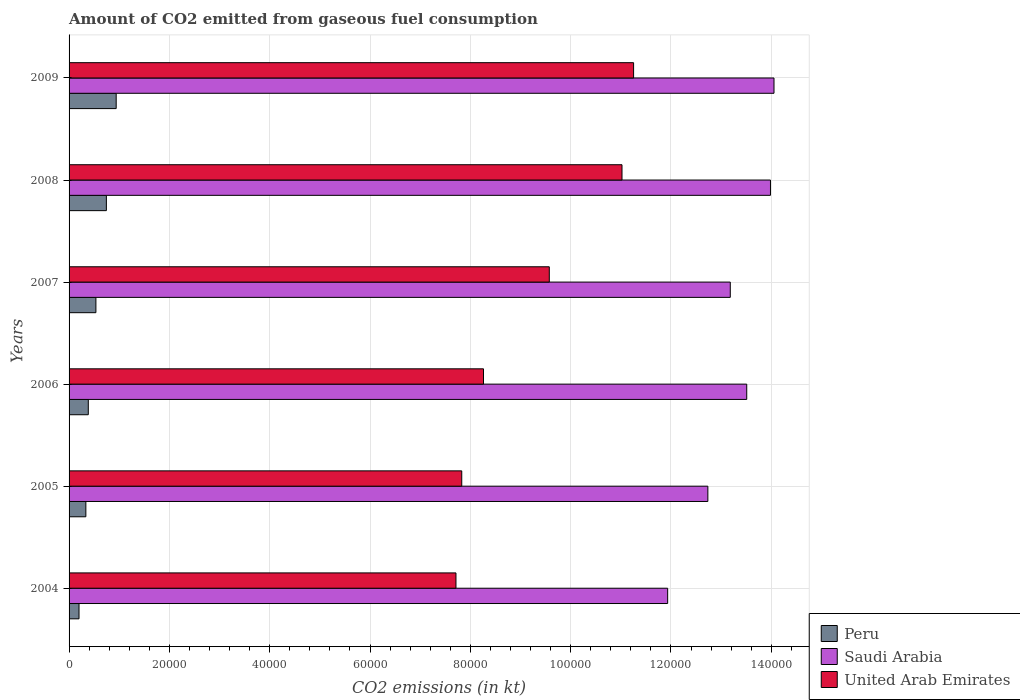Are the number of bars per tick equal to the number of legend labels?
Give a very brief answer. Yes. How many bars are there on the 4th tick from the bottom?
Your answer should be compact. 3. What is the amount of CO2 emitted in Peru in 2008?
Offer a terse response. 7436.68. Across all years, what is the maximum amount of CO2 emitted in Peru?
Keep it short and to the point. 9394.85. Across all years, what is the minimum amount of CO2 emitted in Saudi Arabia?
Offer a very short reply. 1.19e+05. What is the total amount of CO2 emitted in Saudi Arabia in the graph?
Ensure brevity in your answer.  7.94e+05. What is the difference between the amount of CO2 emitted in Peru in 2004 and that in 2006?
Give a very brief answer. -1848.17. What is the difference between the amount of CO2 emitted in United Arab Emirates in 2004 and the amount of CO2 emitted in Peru in 2007?
Keep it short and to the point. 7.18e+04. What is the average amount of CO2 emitted in Saudi Arabia per year?
Keep it short and to the point. 1.32e+05. In the year 2005, what is the difference between the amount of CO2 emitted in Saudi Arabia and amount of CO2 emitted in United Arab Emirates?
Ensure brevity in your answer.  4.91e+04. In how many years, is the amount of CO2 emitted in United Arab Emirates greater than 120000 kt?
Ensure brevity in your answer.  0. What is the ratio of the amount of CO2 emitted in United Arab Emirates in 2006 to that in 2009?
Offer a very short reply. 0.73. Is the amount of CO2 emitted in United Arab Emirates in 2005 less than that in 2006?
Provide a succinct answer. Yes. What is the difference between the highest and the second highest amount of CO2 emitted in Saudi Arabia?
Your answer should be compact. 704.06. What is the difference between the highest and the lowest amount of CO2 emitted in Peru?
Ensure brevity in your answer.  7411.01. In how many years, is the amount of CO2 emitted in United Arab Emirates greater than the average amount of CO2 emitted in United Arab Emirates taken over all years?
Your answer should be very brief. 3. Is the sum of the amount of CO2 emitted in Saudi Arabia in 2007 and 2009 greater than the maximum amount of CO2 emitted in Peru across all years?
Ensure brevity in your answer.  Yes. What does the 2nd bar from the top in 2007 represents?
Your answer should be very brief. Saudi Arabia. What does the 2nd bar from the bottom in 2009 represents?
Keep it short and to the point. Saudi Arabia. Is it the case that in every year, the sum of the amount of CO2 emitted in Saudi Arabia and amount of CO2 emitted in United Arab Emirates is greater than the amount of CO2 emitted in Peru?
Ensure brevity in your answer.  Yes. How many bars are there?
Your answer should be compact. 18. Are all the bars in the graph horizontal?
Offer a very short reply. Yes. How many years are there in the graph?
Offer a very short reply. 6. What is the difference between two consecutive major ticks on the X-axis?
Your answer should be compact. 2.00e+04. Does the graph contain grids?
Provide a succinct answer. Yes. How are the legend labels stacked?
Your response must be concise. Vertical. What is the title of the graph?
Offer a very short reply. Amount of CO2 emitted from gaseous fuel consumption. What is the label or title of the X-axis?
Make the answer very short. CO2 emissions (in kt). What is the label or title of the Y-axis?
Ensure brevity in your answer.  Years. What is the CO2 emissions (in kt) of Peru in 2004?
Keep it short and to the point. 1983.85. What is the CO2 emissions (in kt) in Saudi Arabia in 2004?
Your answer should be very brief. 1.19e+05. What is the CO2 emissions (in kt) in United Arab Emirates in 2004?
Provide a short and direct response. 7.71e+04. What is the CO2 emissions (in kt) of Peru in 2005?
Provide a succinct answer. 3347.97. What is the CO2 emissions (in kt) in Saudi Arabia in 2005?
Make the answer very short. 1.27e+05. What is the CO2 emissions (in kt) of United Arab Emirates in 2005?
Ensure brevity in your answer.  7.83e+04. What is the CO2 emissions (in kt) in Peru in 2006?
Your response must be concise. 3832.01. What is the CO2 emissions (in kt) in Saudi Arabia in 2006?
Ensure brevity in your answer.  1.35e+05. What is the CO2 emissions (in kt) of United Arab Emirates in 2006?
Your response must be concise. 8.26e+04. What is the CO2 emissions (in kt) in Peru in 2007?
Offer a very short reply. 5350.15. What is the CO2 emissions (in kt) of Saudi Arabia in 2007?
Provide a succinct answer. 1.32e+05. What is the CO2 emissions (in kt) of United Arab Emirates in 2007?
Offer a terse response. 9.57e+04. What is the CO2 emissions (in kt) of Peru in 2008?
Offer a terse response. 7436.68. What is the CO2 emissions (in kt) in Saudi Arabia in 2008?
Your answer should be very brief. 1.40e+05. What is the CO2 emissions (in kt) in United Arab Emirates in 2008?
Offer a terse response. 1.10e+05. What is the CO2 emissions (in kt) in Peru in 2009?
Provide a short and direct response. 9394.85. What is the CO2 emissions (in kt) in Saudi Arabia in 2009?
Offer a very short reply. 1.41e+05. What is the CO2 emissions (in kt) in United Arab Emirates in 2009?
Offer a very short reply. 1.13e+05. Across all years, what is the maximum CO2 emissions (in kt) in Peru?
Your response must be concise. 9394.85. Across all years, what is the maximum CO2 emissions (in kt) in Saudi Arabia?
Your answer should be compact. 1.41e+05. Across all years, what is the maximum CO2 emissions (in kt) of United Arab Emirates?
Your answer should be compact. 1.13e+05. Across all years, what is the minimum CO2 emissions (in kt) of Peru?
Keep it short and to the point. 1983.85. Across all years, what is the minimum CO2 emissions (in kt) in Saudi Arabia?
Your answer should be compact. 1.19e+05. Across all years, what is the minimum CO2 emissions (in kt) of United Arab Emirates?
Keep it short and to the point. 7.71e+04. What is the total CO2 emissions (in kt) of Peru in the graph?
Offer a very short reply. 3.13e+04. What is the total CO2 emissions (in kt) of Saudi Arabia in the graph?
Provide a succinct answer. 7.94e+05. What is the total CO2 emissions (in kt) of United Arab Emirates in the graph?
Your answer should be very brief. 5.57e+05. What is the difference between the CO2 emissions (in kt) in Peru in 2004 and that in 2005?
Keep it short and to the point. -1364.12. What is the difference between the CO2 emissions (in kt) of Saudi Arabia in 2004 and that in 2005?
Your answer should be very brief. -8016.06. What is the difference between the CO2 emissions (in kt) of United Arab Emirates in 2004 and that in 2005?
Your response must be concise. -1151.44. What is the difference between the CO2 emissions (in kt) of Peru in 2004 and that in 2006?
Provide a succinct answer. -1848.17. What is the difference between the CO2 emissions (in kt) in Saudi Arabia in 2004 and that in 2006?
Offer a terse response. -1.58e+04. What is the difference between the CO2 emissions (in kt) of United Arab Emirates in 2004 and that in 2006?
Your answer should be very brief. -5489.5. What is the difference between the CO2 emissions (in kt) of Peru in 2004 and that in 2007?
Offer a terse response. -3366.31. What is the difference between the CO2 emissions (in kt) of Saudi Arabia in 2004 and that in 2007?
Your response must be concise. -1.25e+04. What is the difference between the CO2 emissions (in kt) in United Arab Emirates in 2004 and that in 2007?
Make the answer very short. -1.86e+04. What is the difference between the CO2 emissions (in kt) of Peru in 2004 and that in 2008?
Ensure brevity in your answer.  -5452.83. What is the difference between the CO2 emissions (in kt) of Saudi Arabia in 2004 and that in 2008?
Your answer should be compact. -2.05e+04. What is the difference between the CO2 emissions (in kt) in United Arab Emirates in 2004 and that in 2008?
Provide a short and direct response. -3.31e+04. What is the difference between the CO2 emissions (in kt) of Peru in 2004 and that in 2009?
Provide a succinct answer. -7411.01. What is the difference between the CO2 emissions (in kt) in Saudi Arabia in 2004 and that in 2009?
Offer a very short reply. -2.12e+04. What is the difference between the CO2 emissions (in kt) of United Arab Emirates in 2004 and that in 2009?
Offer a very short reply. -3.54e+04. What is the difference between the CO2 emissions (in kt) in Peru in 2005 and that in 2006?
Your answer should be very brief. -484.04. What is the difference between the CO2 emissions (in kt) in Saudi Arabia in 2005 and that in 2006?
Your answer should be compact. -7752.04. What is the difference between the CO2 emissions (in kt) of United Arab Emirates in 2005 and that in 2006?
Make the answer very short. -4338.06. What is the difference between the CO2 emissions (in kt) of Peru in 2005 and that in 2007?
Your response must be concise. -2002.18. What is the difference between the CO2 emissions (in kt) in Saudi Arabia in 2005 and that in 2007?
Your response must be concise. -4470.07. What is the difference between the CO2 emissions (in kt) of United Arab Emirates in 2005 and that in 2007?
Offer a very short reply. -1.75e+04. What is the difference between the CO2 emissions (in kt) of Peru in 2005 and that in 2008?
Make the answer very short. -4088.7. What is the difference between the CO2 emissions (in kt) of Saudi Arabia in 2005 and that in 2008?
Offer a terse response. -1.25e+04. What is the difference between the CO2 emissions (in kt) in United Arab Emirates in 2005 and that in 2008?
Provide a succinct answer. -3.20e+04. What is the difference between the CO2 emissions (in kt) in Peru in 2005 and that in 2009?
Ensure brevity in your answer.  -6046.88. What is the difference between the CO2 emissions (in kt) of Saudi Arabia in 2005 and that in 2009?
Ensure brevity in your answer.  -1.32e+04. What is the difference between the CO2 emissions (in kt) of United Arab Emirates in 2005 and that in 2009?
Ensure brevity in your answer.  -3.43e+04. What is the difference between the CO2 emissions (in kt) in Peru in 2006 and that in 2007?
Offer a terse response. -1518.14. What is the difference between the CO2 emissions (in kt) in Saudi Arabia in 2006 and that in 2007?
Keep it short and to the point. 3281.97. What is the difference between the CO2 emissions (in kt) of United Arab Emirates in 2006 and that in 2007?
Your answer should be compact. -1.31e+04. What is the difference between the CO2 emissions (in kt) in Peru in 2006 and that in 2008?
Your response must be concise. -3604.66. What is the difference between the CO2 emissions (in kt) of Saudi Arabia in 2006 and that in 2008?
Give a very brief answer. -4730.43. What is the difference between the CO2 emissions (in kt) of United Arab Emirates in 2006 and that in 2008?
Your response must be concise. -2.76e+04. What is the difference between the CO2 emissions (in kt) of Peru in 2006 and that in 2009?
Offer a terse response. -5562.84. What is the difference between the CO2 emissions (in kt) of Saudi Arabia in 2006 and that in 2009?
Offer a very short reply. -5434.49. What is the difference between the CO2 emissions (in kt) of United Arab Emirates in 2006 and that in 2009?
Your answer should be compact. -2.99e+04. What is the difference between the CO2 emissions (in kt) in Peru in 2007 and that in 2008?
Make the answer very short. -2086.52. What is the difference between the CO2 emissions (in kt) of Saudi Arabia in 2007 and that in 2008?
Your answer should be very brief. -8012.4. What is the difference between the CO2 emissions (in kt) in United Arab Emirates in 2007 and that in 2008?
Offer a terse response. -1.45e+04. What is the difference between the CO2 emissions (in kt) in Peru in 2007 and that in 2009?
Make the answer very short. -4044.7. What is the difference between the CO2 emissions (in kt) in Saudi Arabia in 2007 and that in 2009?
Make the answer very short. -8716.46. What is the difference between the CO2 emissions (in kt) of United Arab Emirates in 2007 and that in 2009?
Ensure brevity in your answer.  -1.68e+04. What is the difference between the CO2 emissions (in kt) of Peru in 2008 and that in 2009?
Your answer should be very brief. -1958.18. What is the difference between the CO2 emissions (in kt) in Saudi Arabia in 2008 and that in 2009?
Make the answer very short. -704.06. What is the difference between the CO2 emissions (in kt) in United Arab Emirates in 2008 and that in 2009?
Your answer should be very brief. -2310.21. What is the difference between the CO2 emissions (in kt) of Peru in 2004 and the CO2 emissions (in kt) of Saudi Arabia in 2005?
Your answer should be very brief. -1.25e+05. What is the difference between the CO2 emissions (in kt) of Peru in 2004 and the CO2 emissions (in kt) of United Arab Emirates in 2005?
Make the answer very short. -7.63e+04. What is the difference between the CO2 emissions (in kt) in Saudi Arabia in 2004 and the CO2 emissions (in kt) in United Arab Emirates in 2005?
Provide a succinct answer. 4.11e+04. What is the difference between the CO2 emissions (in kt) in Peru in 2004 and the CO2 emissions (in kt) in Saudi Arabia in 2006?
Ensure brevity in your answer.  -1.33e+05. What is the difference between the CO2 emissions (in kt) in Peru in 2004 and the CO2 emissions (in kt) in United Arab Emirates in 2006?
Provide a succinct answer. -8.06e+04. What is the difference between the CO2 emissions (in kt) of Saudi Arabia in 2004 and the CO2 emissions (in kt) of United Arab Emirates in 2006?
Keep it short and to the point. 3.67e+04. What is the difference between the CO2 emissions (in kt) in Peru in 2004 and the CO2 emissions (in kt) in Saudi Arabia in 2007?
Keep it short and to the point. -1.30e+05. What is the difference between the CO2 emissions (in kt) of Peru in 2004 and the CO2 emissions (in kt) of United Arab Emirates in 2007?
Ensure brevity in your answer.  -9.38e+04. What is the difference between the CO2 emissions (in kt) in Saudi Arabia in 2004 and the CO2 emissions (in kt) in United Arab Emirates in 2007?
Offer a terse response. 2.36e+04. What is the difference between the CO2 emissions (in kt) in Peru in 2004 and the CO2 emissions (in kt) in Saudi Arabia in 2008?
Ensure brevity in your answer.  -1.38e+05. What is the difference between the CO2 emissions (in kt) of Peru in 2004 and the CO2 emissions (in kt) of United Arab Emirates in 2008?
Your response must be concise. -1.08e+05. What is the difference between the CO2 emissions (in kt) of Saudi Arabia in 2004 and the CO2 emissions (in kt) of United Arab Emirates in 2008?
Offer a very short reply. 9101.49. What is the difference between the CO2 emissions (in kt) in Peru in 2004 and the CO2 emissions (in kt) in Saudi Arabia in 2009?
Ensure brevity in your answer.  -1.39e+05. What is the difference between the CO2 emissions (in kt) of Peru in 2004 and the CO2 emissions (in kt) of United Arab Emirates in 2009?
Provide a short and direct response. -1.11e+05. What is the difference between the CO2 emissions (in kt) of Saudi Arabia in 2004 and the CO2 emissions (in kt) of United Arab Emirates in 2009?
Offer a very short reply. 6791.28. What is the difference between the CO2 emissions (in kt) in Peru in 2005 and the CO2 emissions (in kt) in Saudi Arabia in 2006?
Provide a succinct answer. -1.32e+05. What is the difference between the CO2 emissions (in kt) in Peru in 2005 and the CO2 emissions (in kt) in United Arab Emirates in 2006?
Offer a very short reply. -7.93e+04. What is the difference between the CO2 emissions (in kt) in Saudi Arabia in 2005 and the CO2 emissions (in kt) in United Arab Emirates in 2006?
Your response must be concise. 4.47e+04. What is the difference between the CO2 emissions (in kt) of Peru in 2005 and the CO2 emissions (in kt) of Saudi Arabia in 2007?
Provide a succinct answer. -1.28e+05. What is the difference between the CO2 emissions (in kt) in Peru in 2005 and the CO2 emissions (in kt) in United Arab Emirates in 2007?
Your response must be concise. -9.24e+04. What is the difference between the CO2 emissions (in kt) in Saudi Arabia in 2005 and the CO2 emissions (in kt) in United Arab Emirates in 2007?
Make the answer very short. 3.16e+04. What is the difference between the CO2 emissions (in kt) of Peru in 2005 and the CO2 emissions (in kt) of Saudi Arabia in 2008?
Your response must be concise. -1.36e+05. What is the difference between the CO2 emissions (in kt) of Peru in 2005 and the CO2 emissions (in kt) of United Arab Emirates in 2008?
Keep it short and to the point. -1.07e+05. What is the difference between the CO2 emissions (in kt) of Saudi Arabia in 2005 and the CO2 emissions (in kt) of United Arab Emirates in 2008?
Keep it short and to the point. 1.71e+04. What is the difference between the CO2 emissions (in kt) of Peru in 2005 and the CO2 emissions (in kt) of Saudi Arabia in 2009?
Provide a succinct answer. -1.37e+05. What is the difference between the CO2 emissions (in kt) of Peru in 2005 and the CO2 emissions (in kt) of United Arab Emirates in 2009?
Offer a very short reply. -1.09e+05. What is the difference between the CO2 emissions (in kt) of Saudi Arabia in 2005 and the CO2 emissions (in kt) of United Arab Emirates in 2009?
Offer a terse response. 1.48e+04. What is the difference between the CO2 emissions (in kt) of Peru in 2006 and the CO2 emissions (in kt) of Saudi Arabia in 2007?
Your answer should be compact. -1.28e+05. What is the difference between the CO2 emissions (in kt) of Peru in 2006 and the CO2 emissions (in kt) of United Arab Emirates in 2007?
Give a very brief answer. -9.19e+04. What is the difference between the CO2 emissions (in kt) of Saudi Arabia in 2006 and the CO2 emissions (in kt) of United Arab Emirates in 2007?
Your response must be concise. 3.94e+04. What is the difference between the CO2 emissions (in kt) in Peru in 2006 and the CO2 emissions (in kt) in Saudi Arabia in 2008?
Make the answer very short. -1.36e+05. What is the difference between the CO2 emissions (in kt) in Peru in 2006 and the CO2 emissions (in kt) in United Arab Emirates in 2008?
Provide a succinct answer. -1.06e+05. What is the difference between the CO2 emissions (in kt) in Saudi Arabia in 2006 and the CO2 emissions (in kt) in United Arab Emirates in 2008?
Offer a very short reply. 2.49e+04. What is the difference between the CO2 emissions (in kt) in Peru in 2006 and the CO2 emissions (in kt) in Saudi Arabia in 2009?
Ensure brevity in your answer.  -1.37e+05. What is the difference between the CO2 emissions (in kt) in Peru in 2006 and the CO2 emissions (in kt) in United Arab Emirates in 2009?
Make the answer very short. -1.09e+05. What is the difference between the CO2 emissions (in kt) in Saudi Arabia in 2006 and the CO2 emissions (in kt) in United Arab Emirates in 2009?
Ensure brevity in your answer.  2.26e+04. What is the difference between the CO2 emissions (in kt) in Peru in 2007 and the CO2 emissions (in kt) in Saudi Arabia in 2008?
Offer a terse response. -1.34e+05. What is the difference between the CO2 emissions (in kt) in Peru in 2007 and the CO2 emissions (in kt) in United Arab Emirates in 2008?
Your response must be concise. -1.05e+05. What is the difference between the CO2 emissions (in kt) of Saudi Arabia in 2007 and the CO2 emissions (in kt) of United Arab Emirates in 2008?
Offer a terse response. 2.16e+04. What is the difference between the CO2 emissions (in kt) of Peru in 2007 and the CO2 emissions (in kt) of Saudi Arabia in 2009?
Your answer should be very brief. -1.35e+05. What is the difference between the CO2 emissions (in kt) of Peru in 2007 and the CO2 emissions (in kt) of United Arab Emirates in 2009?
Keep it short and to the point. -1.07e+05. What is the difference between the CO2 emissions (in kt) in Saudi Arabia in 2007 and the CO2 emissions (in kt) in United Arab Emirates in 2009?
Your answer should be compact. 1.93e+04. What is the difference between the CO2 emissions (in kt) in Peru in 2008 and the CO2 emissions (in kt) in Saudi Arabia in 2009?
Provide a succinct answer. -1.33e+05. What is the difference between the CO2 emissions (in kt) of Peru in 2008 and the CO2 emissions (in kt) of United Arab Emirates in 2009?
Provide a succinct answer. -1.05e+05. What is the difference between the CO2 emissions (in kt) in Saudi Arabia in 2008 and the CO2 emissions (in kt) in United Arab Emirates in 2009?
Your answer should be very brief. 2.73e+04. What is the average CO2 emissions (in kt) in Peru per year?
Your answer should be very brief. 5224.25. What is the average CO2 emissions (in kt) of Saudi Arabia per year?
Offer a terse response. 1.32e+05. What is the average CO2 emissions (in kt) in United Arab Emirates per year?
Provide a short and direct response. 9.28e+04. In the year 2004, what is the difference between the CO2 emissions (in kt) in Peru and CO2 emissions (in kt) in Saudi Arabia?
Your response must be concise. -1.17e+05. In the year 2004, what is the difference between the CO2 emissions (in kt) of Peru and CO2 emissions (in kt) of United Arab Emirates?
Your answer should be very brief. -7.52e+04. In the year 2004, what is the difference between the CO2 emissions (in kt) of Saudi Arabia and CO2 emissions (in kt) of United Arab Emirates?
Give a very brief answer. 4.22e+04. In the year 2005, what is the difference between the CO2 emissions (in kt) in Peru and CO2 emissions (in kt) in Saudi Arabia?
Ensure brevity in your answer.  -1.24e+05. In the year 2005, what is the difference between the CO2 emissions (in kt) of Peru and CO2 emissions (in kt) of United Arab Emirates?
Give a very brief answer. -7.49e+04. In the year 2005, what is the difference between the CO2 emissions (in kt) in Saudi Arabia and CO2 emissions (in kt) in United Arab Emirates?
Provide a short and direct response. 4.91e+04. In the year 2006, what is the difference between the CO2 emissions (in kt) in Peru and CO2 emissions (in kt) in Saudi Arabia?
Give a very brief answer. -1.31e+05. In the year 2006, what is the difference between the CO2 emissions (in kt) in Peru and CO2 emissions (in kt) in United Arab Emirates?
Offer a very short reply. -7.88e+04. In the year 2006, what is the difference between the CO2 emissions (in kt) in Saudi Arabia and CO2 emissions (in kt) in United Arab Emirates?
Keep it short and to the point. 5.25e+04. In the year 2007, what is the difference between the CO2 emissions (in kt) in Peru and CO2 emissions (in kt) in Saudi Arabia?
Provide a succinct answer. -1.26e+05. In the year 2007, what is the difference between the CO2 emissions (in kt) in Peru and CO2 emissions (in kt) in United Arab Emirates?
Ensure brevity in your answer.  -9.04e+04. In the year 2007, what is the difference between the CO2 emissions (in kt) in Saudi Arabia and CO2 emissions (in kt) in United Arab Emirates?
Ensure brevity in your answer.  3.61e+04. In the year 2008, what is the difference between the CO2 emissions (in kt) in Peru and CO2 emissions (in kt) in Saudi Arabia?
Make the answer very short. -1.32e+05. In the year 2008, what is the difference between the CO2 emissions (in kt) in Peru and CO2 emissions (in kt) in United Arab Emirates?
Provide a succinct answer. -1.03e+05. In the year 2008, what is the difference between the CO2 emissions (in kt) in Saudi Arabia and CO2 emissions (in kt) in United Arab Emirates?
Offer a terse response. 2.96e+04. In the year 2009, what is the difference between the CO2 emissions (in kt) of Peru and CO2 emissions (in kt) of Saudi Arabia?
Give a very brief answer. -1.31e+05. In the year 2009, what is the difference between the CO2 emissions (in kt) of Peru and CO2 emissions (in kt) of United Arab Emirates?
Give a very brief answer. -1.03e+05. In the year 2009, what is the difference between the CO2 emissions (in kt) in Saudi Arabia and CO2 emissions (in kt) in United Arab Emirates?
Make the answer very short. 2.80e+04. What is the ratio of the CO2 emissions (in kt) in Peru in 2004 to that in 2005?
Ensure brevity in your answer.  0.59. What is the ratio of the CO2 emissions (in kt) of Saudi Arabia in 2004 to that in 2005?
Ensure brevity in your answer.  0.94. What is the ratio of the CO2 emissions (in kt) of United Arab Emirates in 2004 to that in 2005?
Your response must be concise. 0.99. What is the ratio of the CO2 emissions (in kt) of Peru in 2004 to that in 2006?
Provide a succinct answer. 0.52. What is the ratio of the CO2 emissions (in kt) of Saudi Arabia in 2004 to that in 2006?
Provide a succinct answer. 0.88. What is the ratio of the CO2 emissions (in kt) of United Arab Emirates in 2004 to that in 2006?
Give a very brief answer. 0.93. What is the ratio of the CO2 emissions (in kt) of Peru in 2004 to that in 2007?
Your response must be concise. 0.37. What is the ratio of the CO2 emissions (in kt) of Saudi Arabia in 2004 to that in 2007?
Your answer should be compact. 0.91. What is the ratio of the CO2 emissions (in kt) in United Arab Emirates in 2004 to that in 2007?
Provide a succinct answer. 0.81. What is the ratio of the CO2 emissions (in kt) in Peru in 2004 to that in 2008?
Provide a succinct answer. 0.27. What is the ratio of the CO2 emissions (in kt) of Saudi Arabia in 2004 to that in 2008?
Your response must be concise. 0.85. What is the ratio of the CO2 emissions (in kt) in United Arab Emirates in 2004 to that in 2008?
Provide a short and direct response. 0.7. What is the ratio of the CO2 emissions (in kt) of Peru in 2004 to that in 2009?
Give a very brief answer. 0.21. What is the ratio of the CO2 emissions (in kt) in Saudi Arabia in 2004 to that in 2009?
Your answer should be very brief. 0.85. What is the ratio of the CO2 emissions (in kt) in United Arab Emirates in 2004 to that in 2009?
Ensure brevity in your answer.  0.69. What is the ratio of the CO2 emissions (in kt) of Peru in 2005 to that in 2006?
Offer a terse response. 0.87. What is the ratio of the CO2 emissions (in kt) of Saudi Arabia in 2005 to that in 2006?
Keep it short and to the point. 0.94. What is the ratio of the CO2 emissions (in kt) in United Arab Emirates in 2005 to that in 2006?
Offer a terse response. 0.95. What is the ratio of the CO2 emissions (in kt) in Peru in 2005 to that in 2007?
Ensure brevity in your answer.  0.63. What is the ratio of the CO2 emissions (in kt) in Saudi Arabia in 2005 to that in 2007?
Offer a very short reply. 0.97. What is the ratio of the CO2 emissions (in kt) in United Arab Emirates in 2005 to that in 2007?
Give a very brief answer. 0.82. What is the ratio of the CO2 emissions (in kt) in Peru in 2005 to that in 2008?
Ensure brevity in your answer.  0.45. What is the ratio of the CO2 emissions (in kt) in Saudi Arabia in 2005 to that in 2008?
Offer a very short reply. 0.91. What is the ratio of the CO2 emissions (in kt) in United Arab Emirates in 2005 to that in 2008?
Provide a short and direct response. 0.71. What is the ratio of the CO2 emissions (in kt) of Peru in 2005 to that in 2009?
Your response must be concise. 0.36. What is the ratio of the CO2 emissions (in kt) of Saudi Arabia in 2005 to that in 2009?
Ensure brevity in your answer.  0.91. What is the ratio of the CO2 emissions (in kt) of United Arab Emirates in 2005 to that in 2009?
Your answer should be compact. 0.7. What is the ratio of the CO2 emissions (in kt) in Peru in 2006 to that in 2007?
Your response must be concise. 0.72. What is the ratio of the CO2 emissions (in kt) of Saudi Arabia in 2006 to that in 2007?
Your answer should be very brief. 1.02. What is the ratio of the CO2 emissions (in kt) in United Arab Emirates in 2006 to that in 2007?
Your response must be concise. 0.86. What is the ratio of the CO2 emissions (in kt) of Peru in 2006 to that in 2008?
Make the answer very short. 0.52. What is the ratio of the CO2 emissions (in kt) in Saudi Arabia in 2006 to that in 2008?
Provide a short and direct response. 0.97. What is the ratio of the CO2 emissions (in kt) of United Arab Emirates in 2006 to that in 2008?
Make the answer very short. 0.75. What is the ratio of the CO2 emissions (in kt) of Peru in 2006 to that in 2009?
Your response must be concise. 0.41. What is the ratio of the CO2 emissions (in kt) in Saudi Arabia in 2006 to that in 2009?
Your response must be concise. 0.96. What is the ratio of the CO2 emissions (in kt) in United Arab Emirates in 2006 to that in 2009?
Your answer should be compact. 0.73. What is the ratio of the CO2 emissions (in kt) of Peru in 2007 to that in 2008?
Give a very brief answer. 0.72. What is the ratio of the CO2 emissions (in kt) of Saudi Arabia in 2007 to that in 2008?
Offer a terse response. 0.94. What is the ratio of the CO2 emissions (in kt) in United Arab Emirates in 2007 to that in 2008?
Your response must be concise. 0.87. What is the ratio of the CO2 emissions (in kt) of Peru in 2007 to that in 2009?
Provide a short and direct response. 0.57. What is the ratio of the CO2 emissions (in kt) in Saudi Arabia in 2007 to that in 2009?
Provide a succinct answer. 0.94. What is the ratio of the CO2 emissions (in kt) of United Arab Emirates in 2007 to that in 2009?
Ensure brevity in your answer.  0.85. What is the ratio of the CO2 emissions (in kt) of Peru in 2008 to that in 2009?
Provide a succinct answer. 0.79. What is the ratio of the CO2 emissions (in kt) in Saudi Arabia in 2008 to that in 2009?
Give a very brief answer. 0.99. What is the ratio of the CO2 emissions (in kt) of United Arab Emirates in 2008 to that in 2009?
Your answer should be very brief. 0.98. What is the difference between the highest and the second highest CO2 emissions (in kt) in Peru?
Make the answer very short. 1958.18. What is the difference between the highest and the second highest CO2 emissions (in kt) of Saudi Arabia?
Provide a short and direct response. 704.06. What is the difference between the highest and the second highest CO2 emissions (in kt) in United Arab Emirates?
Your answer should be compact. 2310.21. What is the difference between the highest and the lowest CO2 emissions (in kt) in Peru?
Offer a very short reply. 7411.01. What is the difference between the highest and the lowest CO2 emissions (in kt) in Saudi Arabia?
Ensure brevity in your answer.  2.12e+04. What is the difference between the highest and the lowest CO2 emissions (in kt) of United Arab Emirates?
Offer a very short reply. 3.54e+04. 